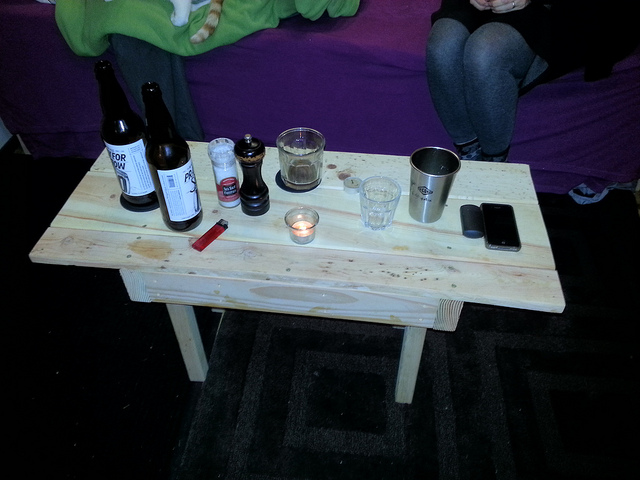Read all the text in this image. FOR 